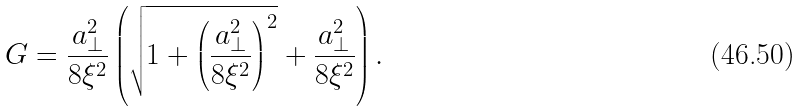Convert formula to latex. <formula><loc_0><loc_0><loc_500><loc_500>G = \frac { a _ { \bot } ^ { 2 } } { 8 \xi ^ { 2 } } \left ( \sqrt { 1 + \left ( \frac { a _ { \bot } ^ { 2 } } { 8 \xi ^ { 2 } } \right ) ^ { 2 } } + \frac { a _ { \bot } ^ { 2 } } { 8 \xi ^ { 2 } } \right ) .</formula> 